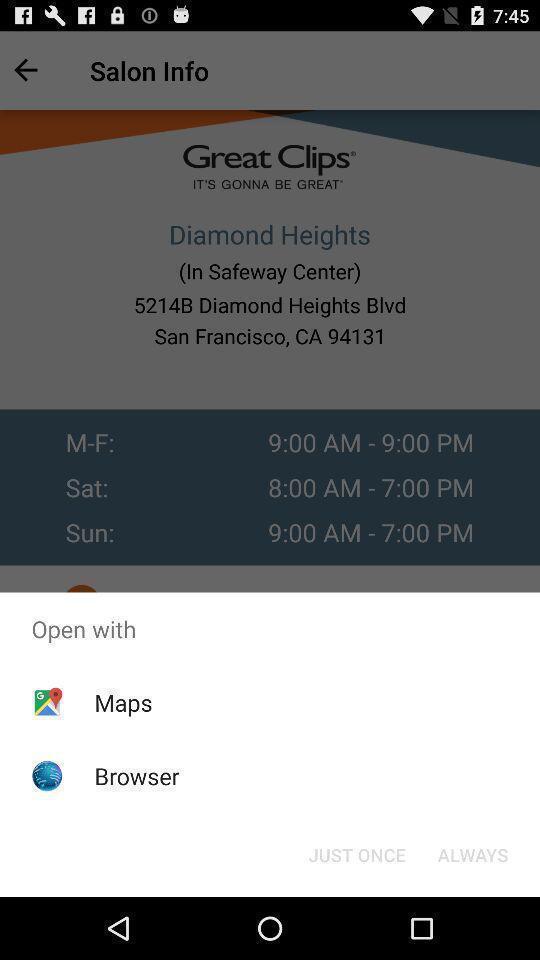Provide a textual representation of this image. Pop-up showing options to open a browser. 